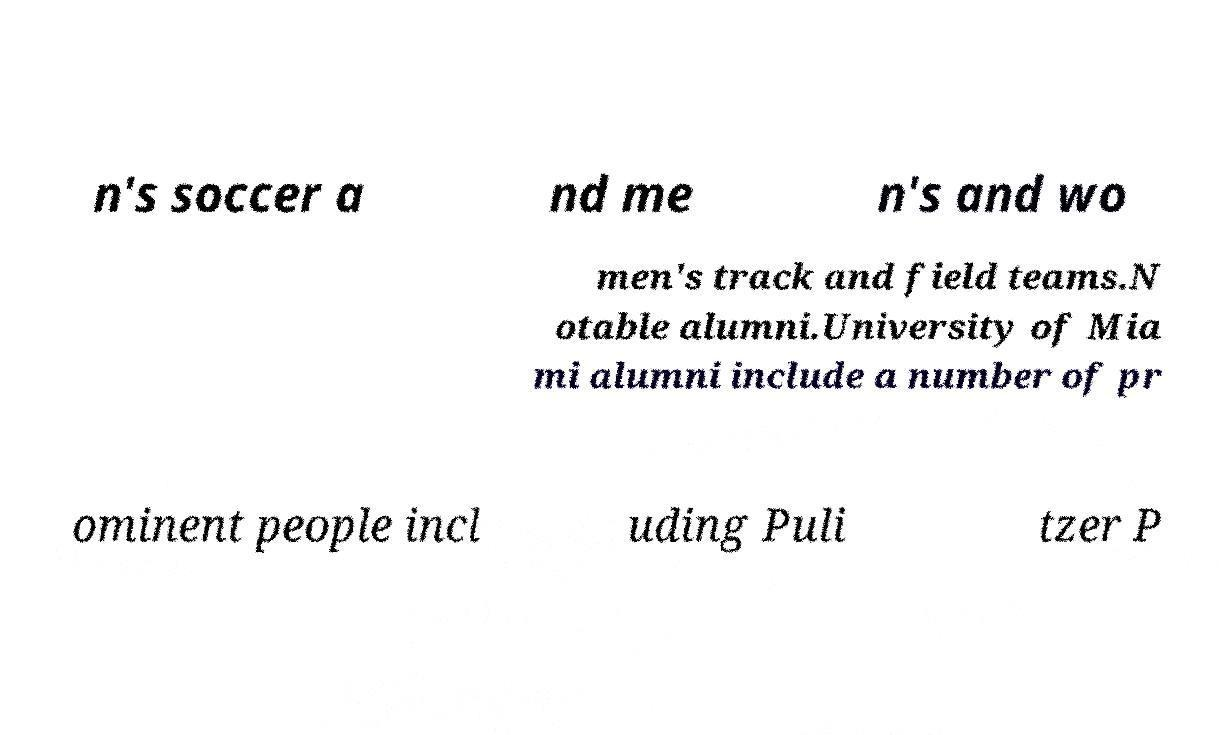There's text embedded in this image that I need extracted. Can you transcribe it verbatim? n's soccer a nd me n's and wo men's track and field teams.N otable alumni.University of Mia mi alumni include a number of pr ominent people incl uding Puli tzer P 